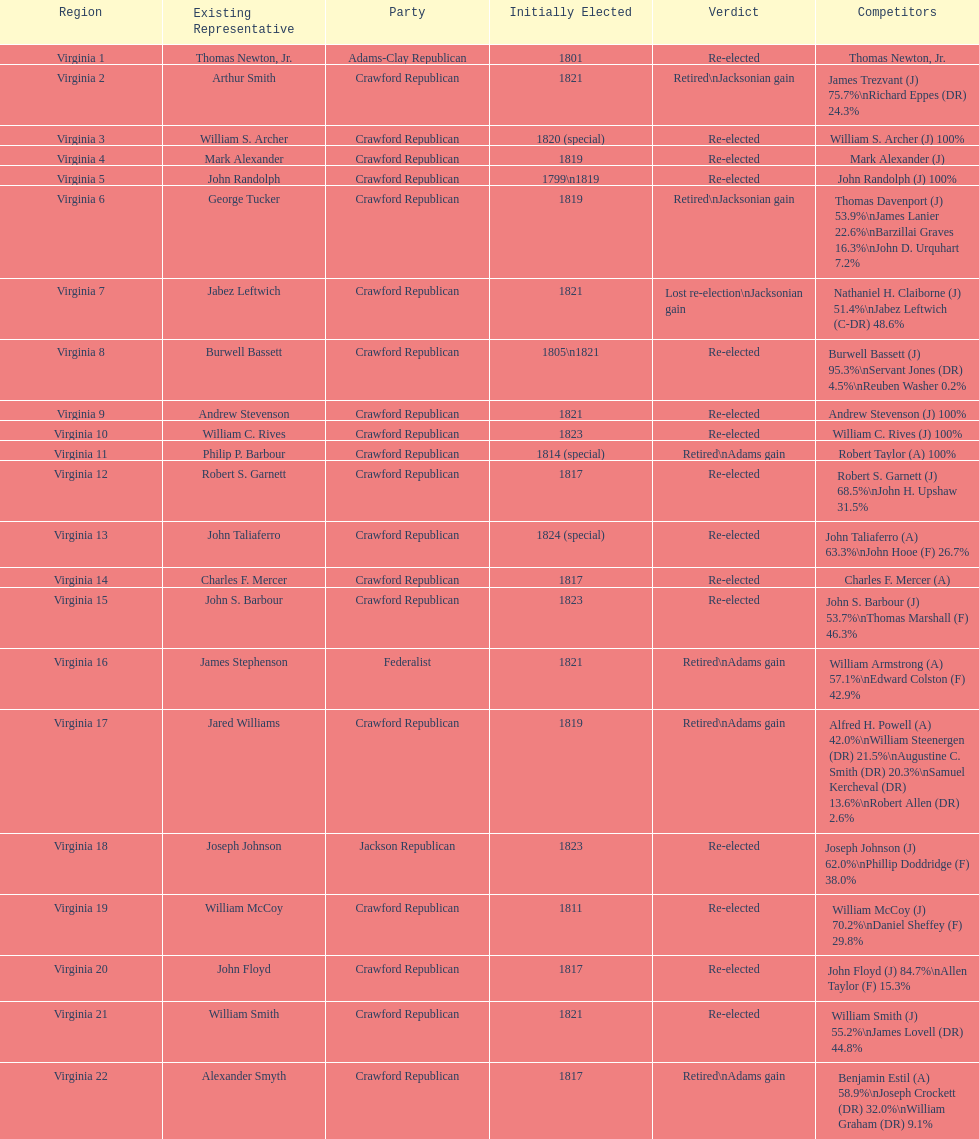Number of incumbents who retired or lost re-election 7. 